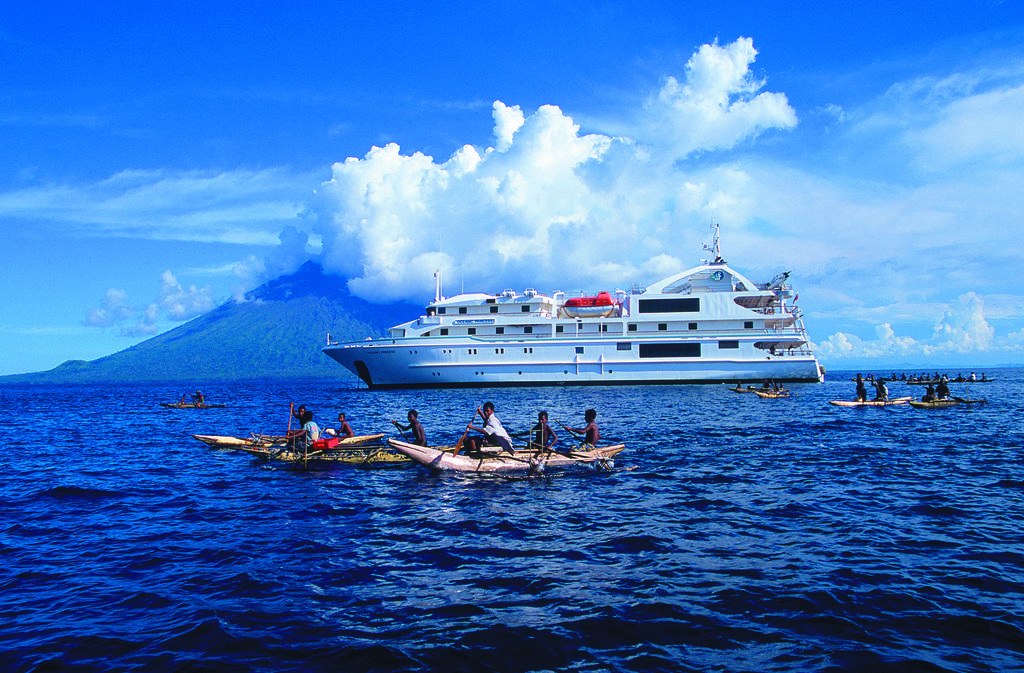What is the main subject of the image? The main subject of the image is a ship. What are the people in the image doing? The people in the image are riding boats on the water. What can be seen in the background of the image? There are hills and the sky visible in the background of the image. What type of wax is being used for the operation in the image? There is no operation or wax present in the image; it features a ship and people riding boats on the water. Is there a veil covering the ship in the image? There is no veil covering the ship in the image; it is visible in its entirety. 